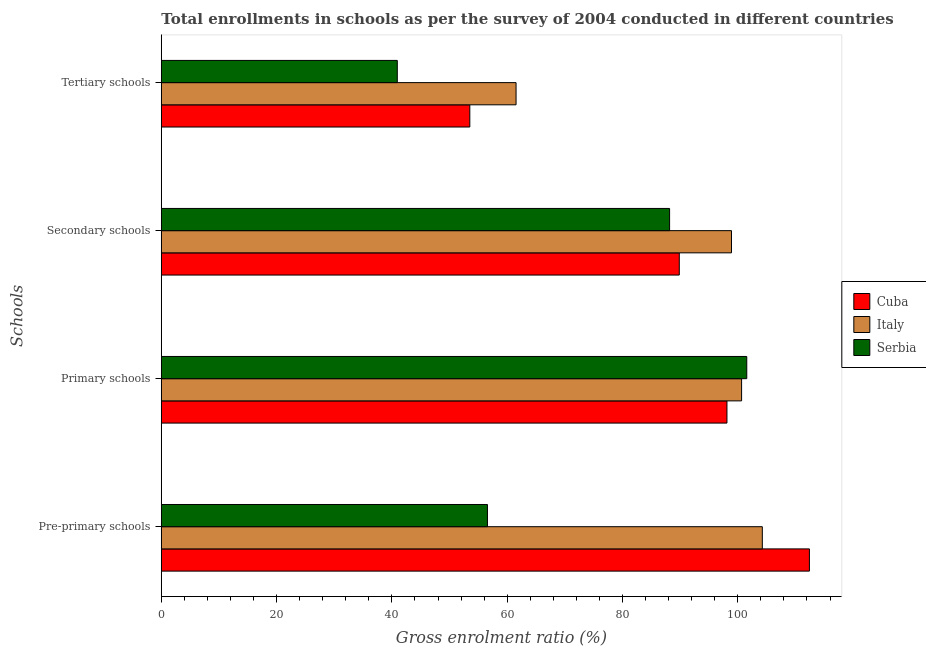How many groups of bars are there?
Your answer should be compact. 4. Are the number of bars per tick equal to the number of legend labels?
Give a very brief answer. Yes. Are the number of bars on each tick of the Y-axis equal?
Keep it short and to the point. Yes. How many bars are there on the 3rd tick from the bottom?
Provide a short and direct response. 3. What is the label of the 3rd group of bars from the top?
Your response must be concise. Primary schools. What is the gross enrolment ratio in secondary schools in Cuba?
Provide a succinct answer. 89.85. Across all countries, what is the maximum gross enrolment ratio in tertiary schools?
Your answer should be very brief. 61.53. Across all countries, what is the minimum gross enrolment ratio in secondary schools?
Your response must be concise. 88.17. In which country was the gross enrolment ratio in pre-primary schools minimum?
Provide a short and direct response. Serbia. What is the total gross enrolment ratio in pre-primary schools in the graph?
Provide a short and direct response. 273.25. What is the difference between the gross enrolment ratio in secondary schools in Italy and that in Cuba?
Ensure brevity in your answer.  9.05. What is the difference between the gross enrolment ratio in pre-primary schools in Serbia and the gross enrolment ratio in secondary schools in Cuba?
Keep it short and to the point. -33.27. What is the average gross enrolment ratio in tertiary schools per country?
Offer a terse response. 51.99. What is the difference between the gross enrolment ratio in tertiary schools and gross enrolment ratio in primary schools in Cuba?
Make the answer very short. -44.6. What is the ratio of the gross enrolment ratio in primary schools in Serbia to that in Italy?
Ensure brevity in your answer.  1.01. Is the difference between the gross enrolment ratio in pre-primary schools in Italy and Serbia greater than the difference between the gross enrolment ratio in tertiary schools in Italy and Serbia?
Your response must be concise. Yes. What is the difference between the highest and the second highest gross enrolment ratio in primary schools?
Your answer should be very brief. 0.9. What is the difference between the highest and the lowest gross enrolment ratio in secondary schools?
Provide a succinct answer. 10.73. Is the sum of the gross enrolment ratio in secondary schools in Italy and Cuba greater than the maximum gross enrolment ratio in primary schools across all countries?
Your answer should be compact. Yes. What does the 1st bar from the top in Primary schools represents?
Offer a very short reply. Serbia. What does the 3rd bar from the bottom in Primary schools represents?
Keep it short and to the point. Serbia. How many bars are there?
Offer a terse response. 12. How many countries are there in the graph?
Your answer should be compact. 3. Are the values on the major ticks of X-axis written in scientific E-notation?
Provide a succinct answer. No. Does the graph contain grids?
Provide a succinct answer. No. How are the legend labels stacked?
Your answer should be very brief. Vertical. What is the title of the graph?
Give a very brief answer. Total enrollments in schools as per the survey of 2004 conducted in different countries. What is the label or title of the Y-axis?
Your response must be concise. Schools. What is the Gross enrolment ratio (%) of Cuba in Pre-primary schools?
Ensure brevity in your answer.  112.42. What is the Gross enrolment ratio (%) of Italy in Pre-primary schools?
Offer a very short reply. 104.25. What is the Gross enrolment ratio (%) of Serbia in Pre-primary schools?
Your response must be concise. 56.57. What is the Gross enrolment ratio (%) of Cuba in Primary schools?
Give a very brief answer. 98.12. What is the Gross enrolment ratio (%) of Italy in Primary schools?
Offer a terse response. 100.66. What is the Gross enrolment ratio (%) of Serbia in Primary schools?
Provide a succinct answer. 101.55. What is the Gross enrolment ratio (%) in Cuba in Secondary schools?
Provide a succinct answer. 89.85. What is the Gross enrolment ratio (%) of Italy in Secondary schools?
Ensure brevity in your answer.  98.9. What is the Gross enrolment ratio (%) of Serbia in Secondary schools?
Your answer should be very brief. 88.17. What is the Gross enrolment ratio (%) in Cuba in Tertiary schools?
Offer a very short reply. 53.51. What is the Gross enrolment ratio (%) in Italy in Tertiary schools?
Give a very brief answer. 61.53. What is the Gross enrolment ratio (%) of Serbia in Tertiary schools?
Provide a short and direct response. 40.93. Across all Schools, what is the maximum Gross enrolment ratio (%) in Cuba?
Offer a terse response. 112.42. Across all Schools, what is the maximum Gross enrolment ratio (%) in Italy?
Provide a succinct answer. 104.25. Across all Schools, what is the maximum Gross enrolment ratio (%) of Serbia?
Your answer should be very brief. 101.55. Across all Schools, what is the minimum Gross enrolment ratio (%) in Cuba?
Provide a succinct answer. 53.51. Across all Schools, what is the minimum Gross enrolment ratio (%) of Italy?
Provide a short and direct response. 61.53. Across all Schools, what is the minimum Gross enrolment ratio (%) in Serbia?
Make the answer very short. 40.93. What is the total Gross enrolment ratio (%) of Cuba in the graph?
Your answer should be compact. 353.89. What is the total Gross enrolment ratio (%) of Italy in the graph?
Provide a short and direct response. 365.35. What is the total Gross enrolment ratio (%) in Serbia in the graph?
Provide a short and direct response. 287.23. What is the difference between the Gross enrolment ratio (%) in Cuba in Pre-primary schools and that in Primary schools?
Your answer should be very brief. 14.3. What is the difference between the Gross enrolment ratio (%) in Italy in Pre-primary schools and that in Primary schools?
Keep it short and to the point. 3.6. What is the difference between the Gross enrolment ratio (%) of Serbia in Pre-primary schools and that in Primary schools?
Give a very brief answer. -44.98. What is the difference between the Gross enrolment ratio (%) of Cuba in Pre-primary schools and that in Secondary schools?
Your response must be concise. 22.57. What is the difference between the Gross enrolment ratio (%) in Italy in Pre-primary schools and that in Secondary schools?
Your answer should be very brief. 5.35. What is the difference between the Gross enrolment ratio (%) in Serbia in Pre-primary schools and that in Secondary schools?
Keep it short and to the point. -31.59. What is the difference between the Gross enrolment ratio (%) of Cuba in Pre-primary schools and that in Tertiary schools?
Keep it short and to the point. 58.91. What is the difference between the Gross enrolment ratio (%) in Italy in Pre-primary schools and that in Tertiary schools?
Ensure brevity in your answer.  42.72. What is the difference between the Gross enrolment ratio (%) of Serbia in Pre-primary schools and that in Tertiary schools?
Your answer should be compact. 15.64. What is the difference between the Gross enrolment ratio (%) of Cuba in Primary schools and that in Secondary schools?
Ensure brevity in your answer.  8.27. What is the difference between the Gross enrolment ratio (%) in Italy in Primary schools and that in Secondary schools?
Give a very brief answer. 1.75. What is the difference between the Gross enrolment ratio (%) of Serbia in Primary schools and that in Secondary schools?
Provide a succinct answer. 13.39. What is the difference between the Gross enrolment ratio (%) of Cuba in Primary schools and that in Tertiary schools?
Your response must be concise. 44.6. What is the difference between the Gross enrolment ratio (%) in Italy in Primary schools and that in Tertiary schools?
Offer a very short reply. 39.12. What is the difference between the Gross enrolment ratio (%) of Serbia in Primary schools and that in Tertiary schools?
Ensure brevity in your answer.  60.62. What is the difference between the Gross enrolment ratio (%) of Cuba in Secondary schools and that in Tertiary schools?
Your answer should be compact. 36.34. What is the difference between the Gross enrolment ratio (%) in Italy in Secondary schools and that in Tertiary schools?
Your answer should be compact. 37.37. What is the difference between the Gross enrolment ratio (%) of Serbia in Secondary schools and that in Tertiary schools?
Your answer should be very brief. 47.23. What is the difference between the Gross enrolment ratio (%) in Cuba in Pre-primary schools and the Gross enrolment ratio (%) in Italy in Primary schools?
Offer a terse response. 11.76. What is the difference between the Gross enrolment ratio (%) of Cuba in Pre-primary schools and the Gross enrolment ratio (%) of Serbia in Primary schools?
Keep it short and to the point. 10.86. What is the difference between the Gross enrolment ratio (%) in Italy in Pre-primary schools and the Gross enrolment ratio (%) in Serbia in Primary schools?
Your answer should be compact. 2.7. What is the difference between the Gross enrolment ratio (%) in Cuba in Pre-primary schools and the Gross enrolment ratio (%) in Italy in Secondary schools?
Your answer should be very brief. 13.52. What is the difference between the Gross enrolment ratio (%) in Cuba in Pre-primary schools and the Gross enrolment ratio (%) in Serbia in Secondary schools?
Make the answer very short. 24.25. What is the difference between the Gross enrolment ratio (%) in Italy in Pre-primary schools and the Gross enrolment ratio (%) in Serbia in Secondary schools?
Offer a terse response. 16.08. What is the difference between the Gross enrolment ratio (%) of Cuba in Pre-primary schools and the Gross enrolment ratio (%) of Italy in Tertiary schools?
Your response must be concise. 50.88. What is the difference between the Gross enrolment ratio (%) of Cuba in Pre-primary schools and the Gross enrolment ratio (%) of Serbia in Tertiary schools?
Ensure brevity in your answer.  71.48. What is the difference between the Gross enrolment ratio (%) of Italy in Pre-primary schools and the Gross enrolment ratio (%) of Serbia in Tertiary schools?
Ensure brevity in your answer.  63.32. What is the difference between the Gross enrolment ratio (%) in Cuba in Primary schools and the Gross enrolment ratio (%) in Italy in Secondary schools?
Keep it short and to the point. -0.79. What is the difference between the Gross enrolment ratio (%) in Cuba in Primary schools and the Gross enrolment ratio (%) in Serbia in Secondary schools?
Make the answer very short. 9.95. What is the difference between the Gross enrolment ratio (%) in Italy in Primary schools and the Gross enrolment ratio (%) in Serbia in Secondary schools?
Provide a short and direct response. 12.49. What is the difference between the Gross enrolment ratio (%) in Cuba in Primary schools and the Gross enrolment ratio (%) in Italy in Tertiary schools?
Make the answer very short. 36.58. What is the difference between the Gross enrolment ratio (%) of Cuba in Primary schools and the Gross enrolment ratio (%) of Serbia in Tertiary schools?
Give a very brief answer. 57.18. What is the difference between the Gross enrolment ratio (%) of Italy in Primary schools and the Gross enrolment ratio (%) of Serbia in Tertiary schools?
Provide a short and direct response. 59.72. What is the difference between the Gross enrolment ratio (%) of Cuba in Secondary schools and the Gross enrolment ratio (%) of Italy in Tertiary schools?
Ensure brevity in your answer.  28.31. What is the difference between the Gross enrolment ratio (%) of Cuba in Secondary schools and the Gross enrolment ratio (%) of Serbia in Tertiary schools?
Ensure brevity in your answer.  48.91. What is the difference between the Gross enrolment ratio (%) in Italy in Secondary schools and the Gross enrolment ratio (%) in Serbia in Tertiary schools?
Ensure brevity in your answer.  57.97. What is the average Gross enrolment ratio (%) in Cuba per Schools?
Your response must be concise. 88.47. What is the average Gross enrolment ratio (%) of Italy per Schools?
Provide a short and direct response. 91.34. What is the average Gross enrolment ratio (%) of Serbia per Schools?
Your answer should be compact. 71.81. What is the difference between the Gross enrolment ratio (%) of Cuba and Gross enrolment ratio (%) of Italy in Pre-primary schools?
Provide a short and direct response. 8.17. What is the difference between the Gross enrolment ratio (%) in Cuba and Gross enrolment ratio (%) in Serbia in Pre-primary schools?
Keep it short and to the point. 55.84. What is the difference between the Gross enrolment ratio (%) of Italy and Gross enrolment ratio (%) of Serbia in Pre-primary schools?
Make the answer very short. 47.68. What is the difference between the Gross enrolment ratio (%) in Cuba and Gross enrolment ratio (%) in Italy in Primary schools?
Offer a terse response. -2.54. What is the difference between the Gross enrolment ratio (%) in Cuba and Gross enrolment ratio (%) in Serbia in Primary schools?
Your answer should be very brief. -3.44. What is the difference between the Gross enrolment ratio (%) of Italy and Gross enrolment ratio (%) of Serbia in Primary schools?
Keep it short and to the point. -0.9. What is the difference between the Gross enrolment ratio (%) of Cuba and Gross enrolment ratio (%) of Italy in Secondary schools?
Your answer should be compact. -9.05. What is the difference between the Gross enrolment ratio (%) in Cuba and Gross enrolment ratio (%) in Serbia in Secondary schools?
Provide a short and direct response. 1.68. What is the difference between the Gross enrolment ratio (%) of Italy and Gross enrolment ratio (%) of Serbia in Secondary schools?
Provide a short and direct response. 10.73. What is the difference between the Gross enrolment ratio (%) in Cuba and Gross enrolment ratio (%) in Italy in Tertiary schools?
Ensure brevity in your answer.  -8.02. What is the difference between the Gross enrolment ratio (%) of Cuba and Gross enrolment ratio (%) of Serbia in Tertiary schools?
Ensure brevity in your answer.  12.58. What is the difference between the Gross enrolment ratio (%) of Italy and Gross enrolment ratio (%) of Serbia in Tertiary schools?
Provide a short and direct response. 20.6. What is the ratio of the Gross enrolment ratio (%) in Cuba in Pre-primary schools to that in Primary schools?
Make the answer very short. 1.15. What is the ratio of the Gross enrolment ratio (%) of Italy in Pre-primary schools to that in Primary schools?
Give a very brief answer. 1.04. What is the ratio of the Gross enrolment ratio (%) of Serbia in Pre-primary schools to that in Primary schools?
Offer a terse response. 0.56. What is the ratio of the Gross enrolment ratio (%) of Cuba in Pre-primary schools to that in Secondary schools?
Offer a very short reply. 1.25. What is the ratio of the Gross enrolment ratio (%) of Italy in Pre-primary schools to that in Secondary schools?
Give a very brief answer. 1.05. What is the ratio of the Gross enrolment ratio (%) in Serbia in Pre-primary schools to that in Secondary schools?
Offer a very short reply. 0.64. What is the ratio of the Gross enrolment ratio (%) in Cuba in Pre-primary schools to that in Tertiary schools?
Offer a very short reply. 2.1. What is the ratio of the Gross enrolment ratio (%) in Italy in Pre-primary schools to that in Tertiary schools?
Offer a very short reply. 1.69. What is the ratio of the Gross enrolment ratio (%) of Serbia in Pre-primary schools to that in Tertiary schools?
Provide a short and direct response. 1.38. What is the ratio of the Gross enrolment ratio (%) of Cuba in Primary schools to that in Secondary schools?
Offer a very short reply. 1.09. What is the ratio of the Gross enrolment ratio (%) of Italy in Primary schools to that in Secondary schools?
Offer a very short reply. 1.02. What is the ratio of the Gross enrolment ratio (%) in Serbia in Primary schools to that in Secondary schools?
Provide a short and direct response. 1.15. What is the ratio of the Gross enrolment ratio (%) of Cuba in Primary schools to that in Tertiary schools?
Your response must be concise. 1.83. What is the ratio of the Gross enrolment ratio (%) in Italy in Primary schools to that in Tertiary schools?
Make the answer very short. 1.64. What is the ratio of the Gross enrolment ratio (%) of Serbia in Primary schools to that in Tertiary schools?
Give a very brief answer. 2.48. What is the ratio of the Gross enrolment ratio (%) in Cuba in Secondary schools to that in Tertiary schools?
Provide a short and direct response. 1.68. What is the ratio of the Gross enrolment ratio (%) of Italy in Secondary schools to that in Tertiary schools?
Your answer should be very brief. 1.61. What is the ratio of the Gross enrolment ratio (%) of Serbia in Secondary schools to that in Tertiary schools?
Make the answer very short. 2.15. What is the difference between the highest and the second highest Gross enrolment ratio (%) in Cuba?
Keep it short and to the point. 14.3. What is the difference between the highest and the second highest Gross enrolment ratio (%) in Italy?
Your response must be concise. 3.6. What is the difference between the highest and the second highest Gross enrolment ratio (%) in Serbia?
Keep it short and to the point. 13.39. What is the difference between the highest and the lowest Gross enrolment ratio (%) in Cuba?
Offer a terse response. 58.91. What is the difference between the highest and the lowest Gross enrolment ratio (%) in Italy?
Keep it short and to the point. 42.72. What is the difference between the highest and the lowest Gross enrolment ratio (%) in Serbia?
Ensure brevity in your answer.  60.62. 